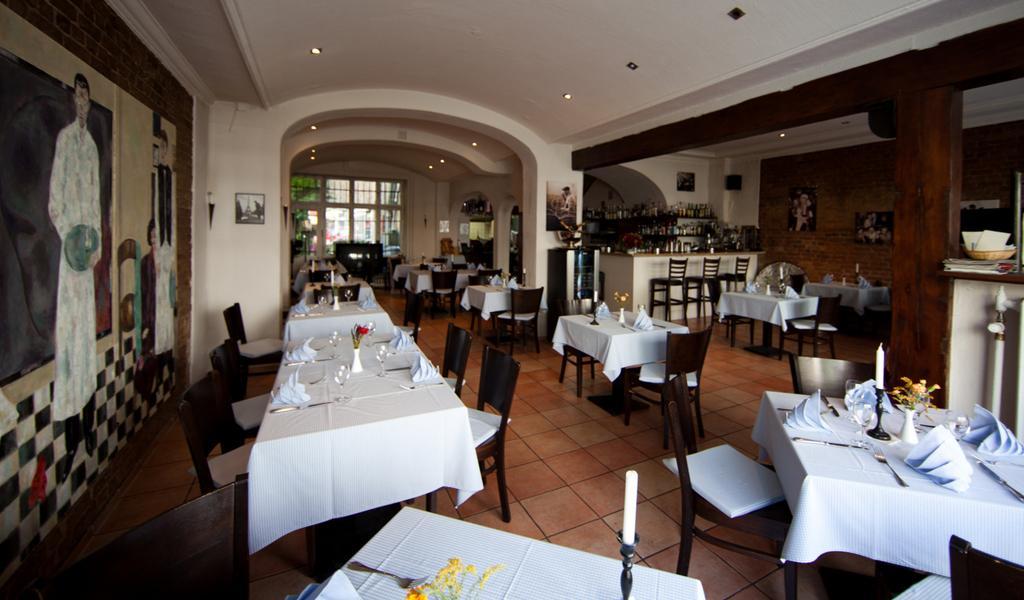Could you give a brief overview of what you see in this image? In this image we can see tables, chairs, clothes, flower vases, for, wall, floor, candles, frames, bottles, ceiling, lights, pillars, and other objects. 